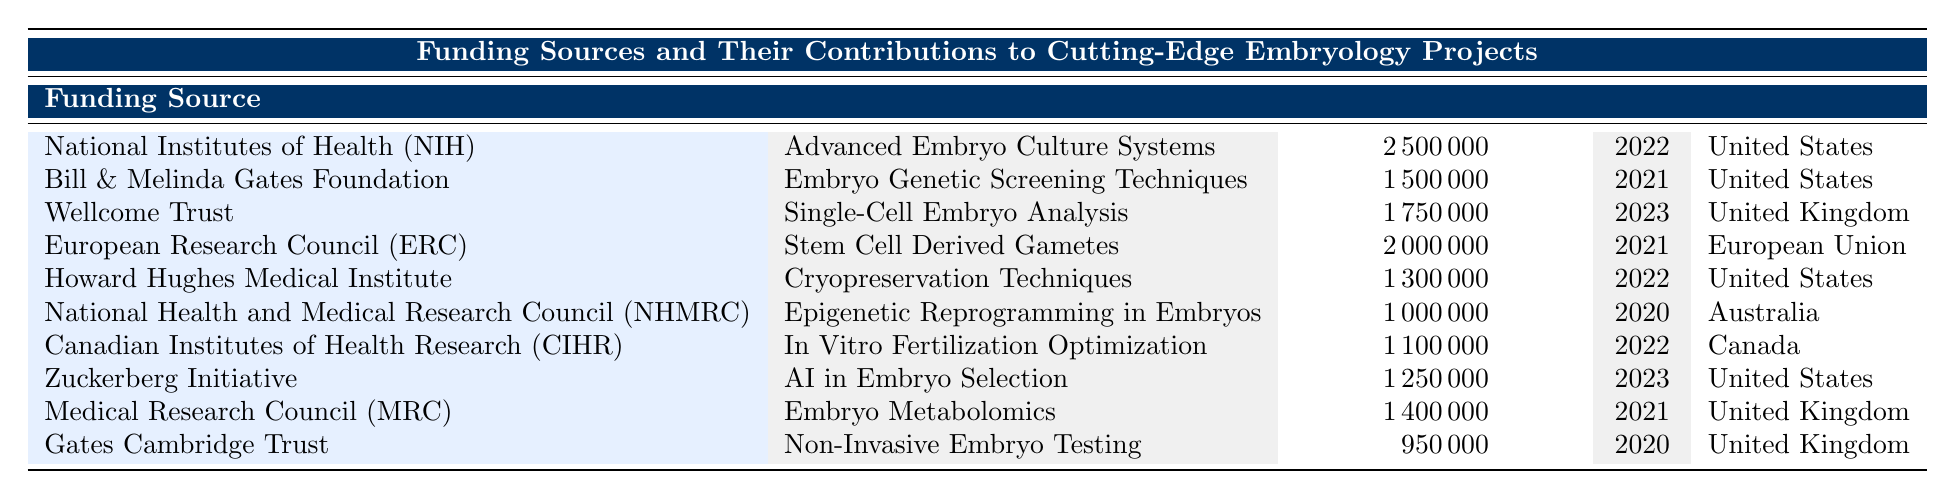What is the highest contribution made by a funding source? The highest contribution is found by looking for the maximum value in the "Contribution (USD)" column. The highest value listed is 2,500,000 from the National Institutes of Health (NIH) for the project "Advanced Embryo Culture Systems."
Answer: 2,500,000 How much funding did the European Research Council contribute? By checking the table, we see the European Research Council contributed 2,000,000 for the "Stem Cell Derived Gametes" project in 2021.
Answer: 2,000,000 Which country has provided funding for the "AI in Embryo Selection" project? We can locate the project "AI in Embryo Selection" in the table and see that it is funded by the Zuckerberg Initiative, and the country listed is the United States.
Answer: United States What was the total contribution from the United States? To find the total contribution from the United States, we add the contributions from the funding sources based there: 2,500,000 (NIH) + 1,500,000 (Bill & Melinda Gates Foundation) + 1,300,000 (Howard Hughes Medical Institute) + 1,250,000 (Zuckerberg Initiative) = 6,550,000.
Answer: 6,550,000 Did the Gates Cambridge Trust fund any projects in 2021? We check the table and find the Gates Cambridge Trust's contribution of 950,000 for the project "Non-Invasive Embryo Testing." However, this funding was in 2020, not 2021. Therefore, the answer is no.
Answer: No How many funding projects received exactly 1,000,000 or less? By reviewing the contributions, we find two projects: "Epigenetic Reprogramming in Embryos" (1,000,000) by NHMRC and "Non-Invasive Embryo Testing" (950,000) by Gates Cambridge Trust. Therefore, the total is 2 projects.
Answer: 2 Which funding source contributed to projects in both 2020 and 2021? Looking at the table, we see the Bill & Melinda Gates Foundation contributed in 2021, and the Gates Cambridge Trust and NHMRC contributed in 2020. However, the only source that contributed in both years is the Gates Cambridge Trust (2020) and Medical Research Council (MRC) (2021) as they both are involved in different projects but only one has contribution which is in a unique year: The answer is no.
Answer: No What is the average funding amount for projects from the United Kingdom? For this, we identify the funding projects from the United Kingdom: "Single-Cell Embryo Analysis" (1,750,000, by Wellcome Trust), "Embryo Metabolomics" (1,400,000, by MRC), and "Non-Invasive Embryo Testing" (950,000, by Gates Cambridge Trust). The total contribution is 1,750,000 + 1,400,000 + 950,000 = 4,100,000, and there are 3 projects. Thus, the average is 4,100,000 / 3 = 1,366,666.67, which we can round to 1,366,667.
Answer: 1,366,667 